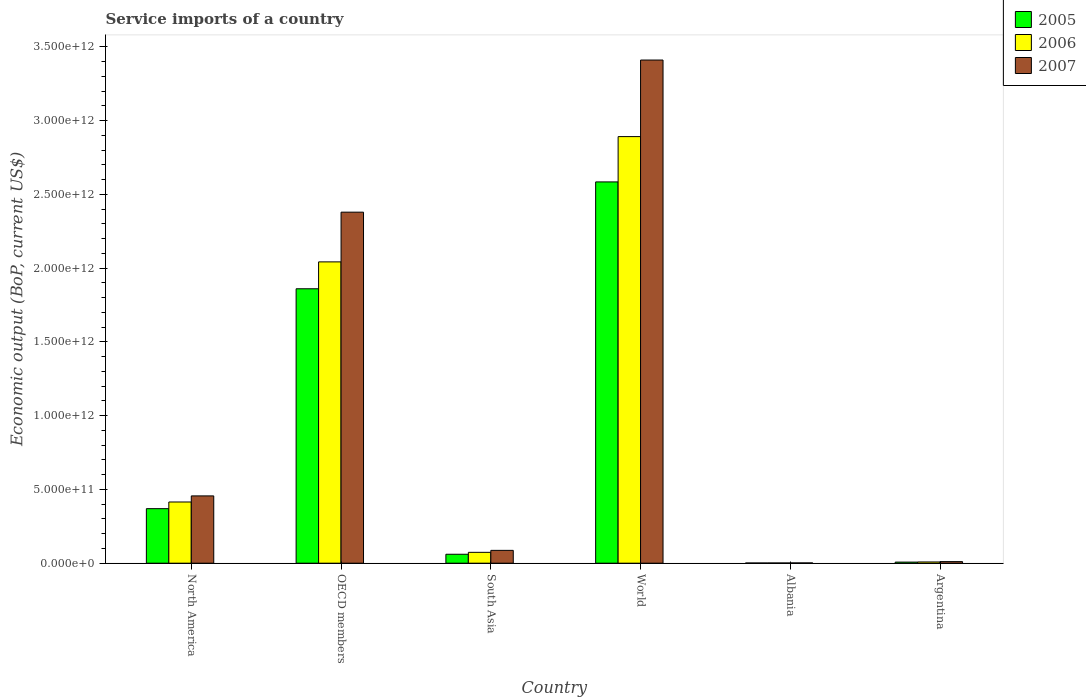How many different coloured bars are there?
Keep it short and to the point. 3. How many bars are there on the 2nd tick from the left?
Provide a short and direct response. 3. What is the label of the 3rd group of bars from the left?
Give a very brief answer. South Asia. In how many cases, is the number of bars for a given country not equal to the number of legend labels?
Your response must be concise. 0. What is the service imports in 2006 in South Asia?
Offer a very short reply. 7.37e+1. Across all countries, what is the maximum service imports in 2007?
Your answer should be very brief. 3.41e+12. Across all countries, what is the minimum service imports in 2007?
Offer a terse response. 1.92e+09. In which country was the service imports in 2006 minimum?
Ensure brevity in your answer.  Albania. What is the total service imports in 2006 in the graph?
Give a very brief answer. 5.43e+12. What is the difference between the service imports in 2006 in OECD members and that in World?
Your response must be concise. -8.49e+11. What is the difference between the service imports in 2005 in Argentina and the service imports in 2006 in OECD members?
Your answer should be compact. -2.04e+12. What is the average service imports in 2005 per country?
Your response must be concise. 8.14e+11. What is the difference between the service imports of/in 2007 and service imports of/in 2006 in Argentina?
Ensure brevity in your answer.  2.32e+09. What is the ratio of the service imports in 2006 in North America to that in South Asia?
Offer a very short reply. 5.63. What is the difference between the highest and the second highest service imports in 2005?
Ensure brevity in your answer.  -1.49e+12. What is the difference between the highest and the lowest service imports in 2006?
Provide a short and direct response. 2.89e+12. In how many countries, is the service imports in 2006 greater than the average service imports in 2006 taken over all countries?
Your response must be concise. 2. How many bars are there?
Offer a very short reply. 18. Are all the bars in the graph horizontal?
Give a very brief answer. No. What is the difference between two consecutive major ticks on the Y-axis?
Offer a very short reply. 5.00e+11. Are the values on the major ticks of Y-axis written in scientific E-notation?
Ensure brevity in your answer.  Yes. Does the graph contain any zero values?
Give a very brief answer. No. Does the graph contain grids?
Keep it short and to the point. No. How many legend labels are there?
Ensure brevity in your answer.  3. What is the title of the graph?
Offer a very short reply. Service imports of a country. Does "2001" appear as one of the legend labels in the graph?
Your answer should be compact. No. What is the label or title of the Y-axis?
Your response must be concise. Economic output (BoP, current US$). What is the Economic output (BoP, current US$) of 2005 in North America?
Provide a short and direct response. 3.70e+11. What is the Economic output (BoP, current US$) in 2006 in North America?
Give a very brief answer. 4.15e+11. What is the Economic output (BoP, current US$) of 2007 in North America?
Your response must be concise. 4.56e+11. What is the Economic output (BoP, current US$) of 2005 in OECD members?
Provide a short and direct response. 1.86e+12. What is the Economic output (BoP, current US$) in 2006 in OECD members?
Your response must be concise. 2.04e+12. What is the Economic output (BoP, current US$) of 2007 in OECD members?
Your response must be concise. 2.38e+12. What is the Economic output (BoP, current US$) in 2005 in South Asia?
Offer a terse response. 6.07e+1. What is the Economic output (BoP, current US$) in 2006 in South Asia?
Your response must be concise. 7.37e+1. What is the Economic output (BoP, current US$) in 2007 in South Asia?
Your answer should be compact. 8.70e+1. What is the Economic output (BoP, current US$) in 2005 in World?
Offer a very short reply. 2.59e+12. What is the Economic output (BoP, current US$) in 2006 in World?
Offer a very short reply. 2.89e+12. What is the Economic output (BoP, current US$) in 2007 in World?
Your answer should be compact. 3.41e+12. What is the Economic output (BoP, current US$) in 2005 in Albania?
Provide a short and direct response. 1.38e+09. What is the Economic output (BoP, current US$) in 2006 in Albania?
Offer a terse response. 1.57e+09. What is the Economic output (BoP, current US$) in 2007 in Albania?
Give a very brief answer. 1.92e+09. What is the Economic output (BoP, current US$) in 2005 in Argentina?
Your answer should be very brief. 7.50e+09. What is the Economic output (BoP, current US$) of 2006 in Argentina?
Your answer should be very brief. 8.39e+09. What is the Economic output (BoP, current US$) in 2007 in Argentina?
Ensure brevity in your answer.  1.07e+1. Across all countries, what is the maximum Economic output (BoP, current US$) in 2005?
Your response must be concise. 2.59e+12. Across all countries, what is the maximum Economic output (BoP, current US$) in 2006?
Make the answer very short. 2.89e+12. Across all countries, what is the maximum Economic output (BoP, current US$) of 2007?
Ensure brevity in your answer.  3.41e+12. Across all countries, what is the minimum Economic output (BoP, current US$) of 2005?
Keep it short and to the point. 1.38e+09. Across all countries, what is the minimum Economic output (BoP, current US$) in 2006?
Provide a short and direct response. 1.57e+09. Across all countries, what is the minimum Economic output (BoP, current US$) in 2007?
Your answer should be compact. 1.92e+09. What is the total Economic output (BoP, current US$) of 2005 in the graph?
Your answer should be compact. 4.89e+12. What is the total Economic output (BoP, current US$) of 2006 in the graph?
Your answer should be very brief. 5.43e+12. What is the total Economic output (BoP, current US$) of 2007 in the graph?
Provide a succinct answer. 6.35e+12. What is the difference between the Economic output (BoP, current US$) of 2005 in North America and that in OECD members?
Offer a terse response. -1.49e+12. What is the difference between the Economic output (BoP, current US$) in 2006 in North America and that in OECD members?
Offer a terse response. -1.63e+12. What is the difference between the Economic output (BoP, current US$) of 2007 in North America and that in OECD members?
Give a very brief answer. -1.92e+12. What is the difference between the Economic output (BoP, current US$) in 2005 in North America and that in South Asia?
Your response must be concise. 3.09e+11. What is the difference between the Economic output (BoP, current US$) of 2006 in North America and that in South Asia?
Provide a short and direct response. 3.41e+11. What is the difference between the Economic output (BoP, current US$) in 2007 in North America and that in South Asia?
Your answer should be compact. 3.69e+11. What is the difference between the Economic output (BoP, current US$) in 2005 in North America and that in World?
Make the answer very short. -2.22e+12. What is the difference between the Economic output (BoP, current US$) in 2006 in North America and that in World?
Your answer should be very brief. -2.48e+12. What is the difference between the Economic output (BoP, current US$) in 2007 in North America and that in World?
Keep it short and to the point. -2.96e+12. What is the difference between the Economic output (BoP, current US$) of 2005 in North America and that in Albania?
Provide a succinct answer. 3.68e+11. What is the difference between the Economic output (BoP, current US$) of 2006 in North America and that in Albania?
Offer a very short reply. 4.13e+11. What is the difference between the Economic output (BoP, current US$) of 2007 in North America and that in Albania?
Your answer should be compact. 4.54e+11. What is the difference between the Economic output (BoP, current US$) in 2005 in North America and that in Argentina?
Your answer should be very brief. 3.62e+11. What is the difference between the Economic output (BoP, current US$) of 2006 in North America and that in Argentina?
Your answer should be compact. 4.07e+11. What is the difference between the Economic output (BoP, current US$) of 2007 in North America and that in Argentina?
Provide a short and direct response. 4.46e+11. What is the difference between the Economic output (BoP, current US$) of 2005 in OECD members and that in South Asia?
Make the answer very short. 1.80e+12. What is the difference between the Economic output (BoP, current US$) in 2006 in OECD members and that in South Asia?
Offer a terse response. 1.97e+12. What is the difference between the Economic output (BoP, current US$) of 2007 in OECD members and that in South Asia?
Your response must be concise. 2.29e+12. What is the difference between the Economic output (BoP, current US$) in 2005 in OECD members and that in World?
Make the answer very short. -7.24e+11. What is the difference between the Economic output (BoP, current US$) of 2006 in OECD members and that in World?
Your response must be concise. -8.49e+11. What is the difference between the Economic output (BoP, current US$) in 2007 in OECD members and that in World?
Your response must be concise. -1.03e+12. What is the difference between the Economic output (BoP, current US$) of 2005 in OECD members and that in Albania?
Offer a terse response. 1.86e+12. What is the difference between the Economic output (BoP, current US$) in 2006 in OECD members and that in Albania?
Keep it short and to the point. 2.04e+12. What is the difference between the Economic output (BoP, current US$) in 2007 in OECD members and that in Albania?
Your answer should be very brief. 2.38e+12. What is the difference between the Economic output (BoP, current US$) in 2005 in OECD members and that in Argentina?
Your answer should be compact. 1.85e+12. What is the difference between the Economic output (BoP, current US$) in 2006 in OECD members and that in Argentina?
Make the answer very short. 2.03e+12. What is the difference between the Economic output (BoP, current US$) of 2007 in OECD members and that in Argentina?
Offer a terse response. 2.37e+12. What is the difference between the Economic output (BoP, current US$) in 2005 in South Asia and that in World?
Keep it short and to the point. -2.52e+12. What is the difference between the Economic output (BoP, current US$) of 2006 in South Asia and that in World?
Provide a short and direct response. -2.82e+12. What is the difference between the Economic output (BoP, current US$) in 2007 in South Asia and that in World?
Make the answer very short. -3.32e+12. What is the difference between the Economic output (BoP, current US$) of 2005 in South Asia and that in Albania?
Keep it short and to the point. 5.93e+1. What is the difference between the Economic output (BoP, current US$) of 2006 in South Asia and that in Albania?
Your response must be concise. 7.21e+1. What is the difference between the Economic output (BoP, current US$) of 2007 in South Asia and that in Albania?
Provide a short and direct response. 8.51e+1. What is the difference between the Economic output (BoP, current US$) in 2005 in South Asia and that in Argentina?
Ensure brevity in your answer.  5.32e+1. What is the difference between the Economic output (BoP, current US$) of 2006 in South Asia and that in Argentina?
Keep it short and to the point. 6.53e+1. What is the difference between the Economic output (BoP, current US$) of 2007 in South Asia and that in Argentina?
Provide a succinct answer. 7.63e+1. What is the difference between the Economic output (BoP, current US$) in 2005 in World and that in Albania?
Keep it short and to the point. 2.58e+12. What is the difference between the Economic output (BoP, current US$) of 2006 in World and that in Albania?
Ensure brevity in your answer.  2.89e+12. What is the difference between the Economic output (BoP, current US$) in 2007 in World and that in Albania?
Your answer should be very brief. 3.41e+12. What is the difference between the Economic output (BoP, current US$) of 2005 in World and that in Argentina?
Offer a terse response. 2.58e+12. What is the difference between the Economic output (BoP, current US$) in 2006 in World and that in Argentina?
Your response must be concise. 2.88e+12. What is the difference between the Economic output (BoP, current US$) in 2007 in World and that in Argentina?
Your answer should be compact. 3.40e+12. What is the difference between the Economic output (BoP, current US$) in 2005 in Albania and that in Argentina?
Keep it short and to the point. -6.11e+09. What is the difference between the Economic output (BoP, current US$) in 2006 in Albania and that in Argentina?
Ensure brevity in your answer.  -6.81e+09. What is the difference between the Economic output (BoP, current US$) in 2007 in Albania and that in Argentina?
Make the answer very short. -8.78e+09. What is the difference between the Economic output (BoP, current US$) in 2005 in North America and the Economic output (BoP, current US$) in 2006 in OECD members?
Keep it short and to the point. -1.67e+12. What is the difference between the Economic output (BoP, current US$) of 2005 in North America and the Economic output (BoP, current US$) of 2007 in OECD members?
Keep it short and to the point. -2.01e+12. What is the difference between the Economic output (BoP, current US$) of 2006 in North America and the Economic output (BoP, current US$) of 2007 in OECD members?
Your answer should be very brief. -1.97e+12. What is the difference between the Economic output (BoP, current US$) of 2005 in North America and the Economic output (BoP, current US$) of 2006 in South Asia?
Your answer should be compact. 2.96e+11. What is the difference between the Economic output (BoP, current US$) of 2005 in North America and the Economic output (BoP, current US$) of 2007 in South Asia?
Provide a short and direct response. 2.83e+11. What is the difference between the Economic output (BoP, current US$) of 2006 in North America and the Economic output (BoP, current US$) of 2007 in South Asia?
Give a very brief answer. 3.28e+11. What is the difference between the Economic output (BoP, current US$) in 2005 in North America and the Economic output (BoP, current US$) in 2006 in World?
Ensure brevity in your answer.  -2.52e+12. What is the difference between the Economic output (BoP, current US$) in 2005 in North America and the Economic output (BoP, current US$) in 2007 in World?
Give a very brief answer. -3.04e+12. What is the difference between the Economic output (BoP, current US$) of 2006 in North America and the Economic output (BoP, current US$) of 2007 in World?
Your answer should be very brief. -3.00e+12. What is the difference between the Economic output (BoP, current US$) of 2005 in North America and the Economic output (BoP, current US$) of 2006 in Albania?
Offer a terse response. 3.68e+11. What is the difference between the Economic output (BoP, current US$) in 2005 in North America and the Economic output (BoP, current US$) in 2007 in Albania?
Provide a short and direct response. 3.68e+11. What is the difference between the Economic output (BoP, current US$) in 2006 in North America and the Economic output (BoP, current US$) in 2007 in Albania?
Give a very brief answer. 4.13e+11. What is the difference between the Economic output (BoP, current US$) of 2005 in North America and the Economic output (BoP, current US$) of 2006 in Argentina?
Keep it short and to the point. 3.61e+11. What is the difference between the Economic output (BoP, current US$) in 2005 in North America and the Economic output (BoP, current US$) in 2007 in Argentina?
Your response must be concise. 3.59e+11. What is the difference between the Economic output (BoP, current US$) of 2006 in North America and the Economic output (BoP, current US$) of 2007 in Argentina?
Provide a succinct answer. 4.04e+11. What is the difference between the Economic output (BoP, current US$) of 2005 in OECD members and the Economic output (BoP, current US$) of 2006 in South Asia?
Provide a succinct answer. 1.79e+12. What is the difference between the Economic output (BoP, current US$) in 2005 in OECD members and the Economic output (BoP, current US$) in 2007 in South Asia?
Your answer should be very brief. 1.77e+12. What is the difference between the Economic output (BoP, current US$) of 2006 in OECD members and the Economic output (BoP, current US$) of 2007 in South Asia?
Make the answer very short. 1.96e+12. What is the difference between the Economic output (BoP, current US$) in 2005 in OECD members and the Economic output (BoP, current US$) in 2006 in World?
Your answer should be compact. -1.03e+12. What is the difference between the Economic output (BoP, current US$) of 2005 in OECD members and the Economic output (BoP, current US$) of 2007 in World?
Provide a short and direct response. -1.55e+12. What is the difference between the Economic output (BoP, current US$) in 2006 in OECD members and the Economic output (BoP, current US$) in 2007 in World?
Ensure brevity in your answer.  -1.37e+12. What is the difference between the Economic output (BoP, current US$) of 2005 in OECD members and the Economic output (BoP, current US$) of 2006 in Albania?
Keep it short and to the point. 1.86e+12. What is the difference between the Economic output (BoP, current US$) in 2005 in OECD members and the Economic output (BoP, current US$) in 2007 in Albania?
Your response must be concise. 1.86e+12. What is the difference between the Economic output (BoP, current US$) in 2006 in OECD members and the Economic output (BoP, current US$) in 2007 in Albania?
Offer a terse response. 2.04e+12. What is the difference between the Economic output (BoP, current US$) of 2005 in OECD members and the Economic output (BoP, current US$) of 2006 in Argentina?
Give a very brief answer. 1.85e+12. What is the difference between the Economic output (BoP, current US$) in 2005 in OECD members and the Economic output (BoP, current US$) in 2007 in Argentina?
Your answer should be very brief. 1.85e+12. What is the difference between the Economic output (BoP, current US$) of 2006 in OECD members and the Economic output (BoP, current US$) of 2007 in Argentina?
Make the answer very short. 2.03e+12. What is the difference between the Economic output (BoP, current US$) of 2005 in South Asia and the Economic output (BoP, current US$) of 2006 in World?
Ensure brevity in your answer.  -2.83e+12. What is the difference between the Economic output (BoP, current US$) of 2005 in South Asia and the Economic output (BoP, current US$) of 2007 in World?
Offer a very short reply. -3.35e+12. What is the difference between the Economic output (BoP, current US$) of 2006 in South Asia and the Economic output (BoP, current US$) of 2007 in World?
Provide a succinct answer. -3.34e+12. What is the difference between the Economic output (BoP, current US$) of 2005 in South Asia and the Economic output (BoP, current US$) of 2006 in Albania?
Make the answer very short. 5.91e+1. What is the difference between the Economic output (BoP, current US$) in 2005 in South Asia and the Economic output (BoP, current US$) in 2007 in Albania?
Provide a short and direct response. 5.87e+1. What is the difference between the Economic output (BoP, current US$) in 2006 in South Asia and the Economic output (BoP, current US$) in 2007 in Albania?
Offer a terse response. 7.18e+1. What is the difference between the Economic output (BoP, current US$) of 2005 in South Asia and the Economic output (BoP, current US$) of 2006 in Argentina?
Offer a very short reply. 5.23e+1. What is the difference between the Economic output (BoP, current US$) in 2005 in South Asia and the Economic output (BoP, current US$) in 2007 in Argentina?
Offer a very short reply. 5.00e+1. What is the difference between the Economic output (BoP, current US$) in 2006 in South Asia and the Economic output (BoP, current US$) in 2007 in Argentina?
Ensure brevity in your answer.  6.30e+1. What is the difference between the Economic output (BoP, current US$) of 2005 in World and the Economic output (BoP, current US$) of 2006 in Albania?
Offer a terse response. 2.58e+12. What is the difference between the Economic output (BoP, current US$) in 2005 in World and the Economic output (BoP, current US$) in 2007 in Albania?
Ensure brevity in your answer.  2.58e+12. What is the difference between the Economic output (BoP, current US$) in 2006 in World and the Economic output (BoP, current US$) in 2007 in Albania?
Give a very brief answer. 2.89e+12. What is the difference between the Economic output (BoP, current US$) of 2005 in World and the Economic output (BoP, current US$) of 2006 in Argentina?
Give a very brief answer. 2.58e+12. What is the difference between the Economic output (BoP, current US$) of 2005 in World and the Economic output (BoP, current US$) of 2007 in Argentina?
Keep it short and to the point. 2.57e+12. What is the difference between the Economic output (BoP, current US$) in 2006 in World and the Economic output (BoP, current US$) in 2007 in Argentina?
Your response must be concise. 2.88e+12. What is the difference between the Economic output (BoP, current US$) in 2005 in Albania and the Economic output (BoP, current US$) in 2006 in Argentina?
Your answer should be compact. -7.00e+09. What is the difference between the Economic output (BoP, current US$) of 2005 in Albania and the Economic output (BoP, current US$) of 2007 in Argentina?
Keep it short and to the point. -9.32e+09. What is the difference between the Economic output (BoP, current US$) in 2006 in Albania and the Economic output (BoP, current US$) in 2007 in Argentina?
Make the answer very short. -9.13e+09. What is the average Economic output (BoP, current US$) of 2005 per country?
Offer a terse response. 8.14e+11. What is the average Economic output (BoP, current US$) of 2006 per country?
Provide a short and direct response. 9.06e+11. What is the average Economic output (BoP, current US$) of 2007 per country?
Make the answer very short. 1.06e+12. What is the difference between the Economic output (BoP, current US$) of 2005 and Economic output (BoP, current US$) of 2006 in North America?
Your answer should be very brief. -4.52e+1. What is the difference between the Economic output (BoP, current US$) in 2005 and Economic output (BoP, current US$) in 2007 in North America?
Provide a short and direct response. -8.65e+1. What is the difference between the Economic output (BoP, current US$) in 2006 and Economic output (BoP, current US$) in 2007 in North America?
Keep it short and to the point. -4.13e+1. What is the difference between the Economic output (BoP, current US$) of 2005 and Economic output (BoP, current US$) of 2006 in OECD members?
Give a very brief answer. -1.82e+11. What is the difference between the Economic output (BoP, current US$) in 2005 and Economic output (BoP, current US$) in 2007 in OECD members?
Provide a short and direct response. -5.19e+11. What is the difference between the Economic output (BoP, current US$) in 2006 and Economic output (BoP, current US$) in 2007 in OECD members?
Your answer should be very brief. -3.37e+11. What is the difference between the Economic output (BoP, current US$) of 2005 and Economic output (BoP, current US$) of 2006 in South Asia?
Ensure brevity in your answer.  -1.30e+1. What is the difference between the Economic output (BoP, current US$) of 2005 and Economic output (BoP, current US$) of 2007 in South Asia?
Make the answer very short. -2.64e+1. What is the difference between the Economic output (BoP, current US$) in 2006 and Economic output (BoP, current US$) in 2007 in South Asia?
Your answer should be compact. -1.34e+1. What is the difference between the Economic output (BoP, current US$) in 2005 and Economic output (BoP, current US$) in 2006 in World?
Give a very brief answer. -3.07e+11. What is the difference between the Economic output (BoP, current US$) of 2005 and Economic output (BoP, current US$) of 2007 in World?
Ensure brevity in your answer.  -8.26e+11. What is the difference between the Economic output (BoP, current US$) of 2006 and Economic output (BoP, current US$) of 2007 in World?
Give a very brief answer. -5.19e+11. What is the difference between the Economic output (BoP, current US$) in 2005 and Economic output (BoP, current US$) in 2006 in Albania?
Ensure brevity in your answer.  -1.90e+08. What is the difference between the Economic output (BoP, current US$) in 2005 and Economic output (BoP, current US$) in 2007 in Albania?
Make the answer very short. -5.42e+08. What is the difference between the Economic output (BoP, current US$) of 2006 and Economic output (BoP, current US$) of 2007 in Albania?
Your response must be concise. -3.51e+08. What is the difference between the Economic output (BoP, current US$) in 2005 and Economic output (BoP, current US$) in 2006 in Argentina?
Make the answer very short. -8.89e+08. What is the difference between the Economic output (BoP, current US$) in 2005 and Economic output (BoP, current US$) in 2007 in Argentina?
Your answer should be very brief. -3.20e+09. What is the difference between the Economic output (BoP, current US$) in 2006 and Economic output (BoP, current US$) in 2007 in Argentina?
Provide a succinct answer. -2.32e+09. What is the ratio of the Economic output (BoP, current US$) of 2005 in North America to that in OECD members?
Keep it short and to the point. 0.2. What is the ratio of the Economic output (BoP, current US$) of 2006 in North America to that in OECD members?
Provide a succinct answer. 0.2. What is the ratio of the Economic output (BoP, current US$) in 2007 in North America to that in OECD members?
Your answer should be compact. 0.19. What is the ratio of the Economic output (BoP, current US$) in 2005 in North America to that in South Asia?
Keep it short and to the point. 6.1. What is the ratio of the Economic output (BoP, current US$) of 2006 in North America to that in South Asia?
Offer a terse response. 5.63. What is the ratio of the Economic output (BoP, current US$) of 2007 in North America to that in South Asia?
Your answer should be very brief. 5.24. What is the ratio of the Economic output (BoP, current US$) of 2005 in North America to that in World?
Offer a very short reply. 0.14. What is the ratio of the Economic output (BoP, current US$) in 2006 in North America to that in World?
Make the answer very short. 0.14. What is the ratio of the Economic output (BoP, current US$) of 2007 in North America to that in World?
Offer a very short reply. 0.13. What is the ratio of the Economic output (BoP, current US$) of 2005 in North America to that in Albania?
Ensure brevity in your answer.  267.41. What is the ratio of the Economic output (BoP, current US$) of 2006 in North America to that in Albania?
Your response must be concise. 263.75. What is the ratio of the Economic output (BoP, current US$) in 2007 in North America to that in Albania?
Ensure brevity in your answer.  237.09. What is the ratio of the Economic output (BoP, current US$) in 2005 in North America to that in Argentina?
Provide a succinct answer. 49.33. What is the ratio of the Economic output (BoP, current US$) in 2006 in North America to that in Argentina?
Provide a succinct answer. 49.49. What is the ratio of the Economic output (BoP, current US$) in 2007 in North America to that in Argentina?
Your response must be concise. 42.63. What is the ratio of the Economic output (BoP, current US$) in 2005 in OECD members to that in South Asia?
Provide a succinct answer. 30.67. What is the ratio of the Economic output (BoP, current US$) in 2006 in OECD members to that in South Asia?
Offer a terse response. 27.73. What is the ratio of the Economic output (BoP, current US$) in 2007 in OECD members to that in South Asia?
Ensure brevity in your answer.  27.35. What is the ratio of the Economic output (BoP, current US$) in 2005 in OECD members to that in World?
Ensure brevity in your answer.  0.72. What is the ratio of the Economic output (BoP, current US$) in 2006 in OECD members to that in World?
Give a very brief answer. 0.71. What is the ratio of the Economic output (BoP, current US$) in 2007 in OECD members to that in World?
Provide a short and direct response. 0.7. What is the ratio of the Economic output (BoP, current US$) in 2005 in OECD members to that in Albania?
Your response must be concise. 1345.46. What is the ratio of the Economic output (BoP, current US$) in 2006 in OECD members to that in Albania?
Provide a succinct answer. 1298.43. What is the ratio of the Economic output (BoP, current US$) of 2007 in OECD members to that in Albania?
Offer a terse response. 1236.72. What is the ratio of the Economic output (BoP, current US$) in 2005 in OECD members to that in Argentina?
Keep it short and to the point. 248.19. What is the ratio of the Economic output (BoP, current US$) of 2006 in OECD members to that in Argentina?
Keep it short and to the point. 243.62. What is the ratio of the Economic output (BoP, current US$) of 2007 in OECD members to that in Argentina?
Your answer should be very brief. 222.39. What is the ratio of the Economic output (BoP, current US$) in 2005 in South Asia to that in World?
Give a very brief answer. 0.02. What is the ratio of the Economic output (BoP, current US$) in 2006 in South Asia to that in World?
Your answer should be very brief. 0.03. What is the ratio of the Economic output (BoP, current US$) of 2007 in South Asia to that in World?
Your answer should be compact. 0.03. What is the ratio of the Economic output (BoP, current US$) in 2005 in South Asia to that in Albania?
Make the answer very short. 43.87. What is the ratio of the Economic output (BoP, current US$) of 2006 in South Asia to that in Albania?
Offer a terse response. 46.83. What is the ratio of the Economic output (BoP, current US$) in 2007 in South Asia to that in Albania?
Keep it short and to the point. 45.22. What is the ratio of the Economic output (BoP, current US$) of 2005 in South Asia to that in Argentina?
Offer a terse response. 8.09. What is the ratio of the Economic output (BoP, current US$) in 2006 in South Asia to that in Argentina?
Provide a succinct answer. 8.79. What is the ratio of the Economic output (BoP, current US$) in 2007 in South Asia to that in Argentina?
Ensure brevity in your answer.  8.13. What is the ratio of the Economic output (BoP, current US$) of 2005 in World to that in Albania?
Keep it short and to the point. 1869.34. What is the ratio of the Economic output (BoP, current US$) of 2006 in World to that in Albania?
Keep it short and to the point. 1838.32. What is the ratio of the Economic output (BoP, current US$) in 2007 in World to that in Albania?
Offer a very short reply. 1772.68. What is the ratio of the Economic output (BoP, current US$) in 2005 in World to that in Argentina?
Ensure brevity in your answer.  344.82. What is the ratio of the Economic output (BoP, current US$) of 2006 in World to that in Argentina?
Your answer should be very brief. 344.91. What is the ratio of the Economic output (BoP, current US$) of 2007 in World to that in Argentina?
Offer a terse response. 318.77. What is the ratio of the Economic output (BoP, current US$) of 2005 in Albania to that in Argentina?
Make the answer very short. 0.18. What is the ratio of the Economic output (BoP, current US$) in 2006 in Albania to that in Argentina?
Provide a short and direct response. 0.19. What is the ratio of the Economic output (BoP, current US$) of 2007 in Albania to that in Argentina?
Ensure brevity in your answer.  0.18. What is the difference between the highest and the second highest Economic output (BoP, current US$) in 2005?
Provide a succinct answer. 7.24e+11. What is the difference between the highest and the second highest Economic output (BoP, current US$) of 2006?
Your response must be concise. 8.49e+11. What is the difference between the highest and the second highest Economic output (BoP, current US$) in 2007?
Offer a very short reply. 1.03e+12. What is the difference between the highest and the lowest Economic output (BoP, current US$) of 2005?
Provide a short and direct response. 2.58e+12. What is the difference between the highest and the lowest Economic output (BoP, current US$) of 2006?
Offer a terse response. 2.89e+12. What is the difference between the highest and the lowest Economic output (BoP, current US$) of 2007?
Provide a short and direct response. 3.41e+12. 